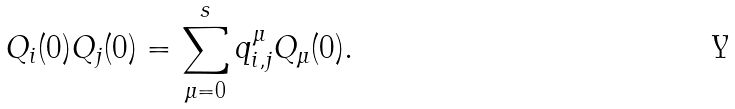<formula> <loc_0><loc_0><loc_500><loc_500>Q _ { i } ( 0 ) Q _ { j } ( 0 ) = \sum _ { \mu = 0 } ^ { s } q _ { i , j } ^ { \mu } Q _ { \mu } ( 0 ) .</formula> 